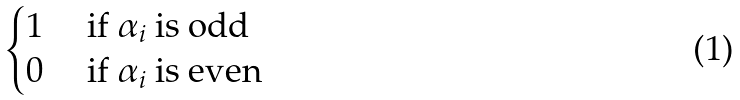Convert formula to latex. <formula><loc_0><loc_0><loc_500><loc_500>\begin{cases} 1 & \text { if } \alpha _ { i } \text { is odd} \\ 0 & \text { if } \alpha _ { i } \text { is even} \end{cases}</formula> 